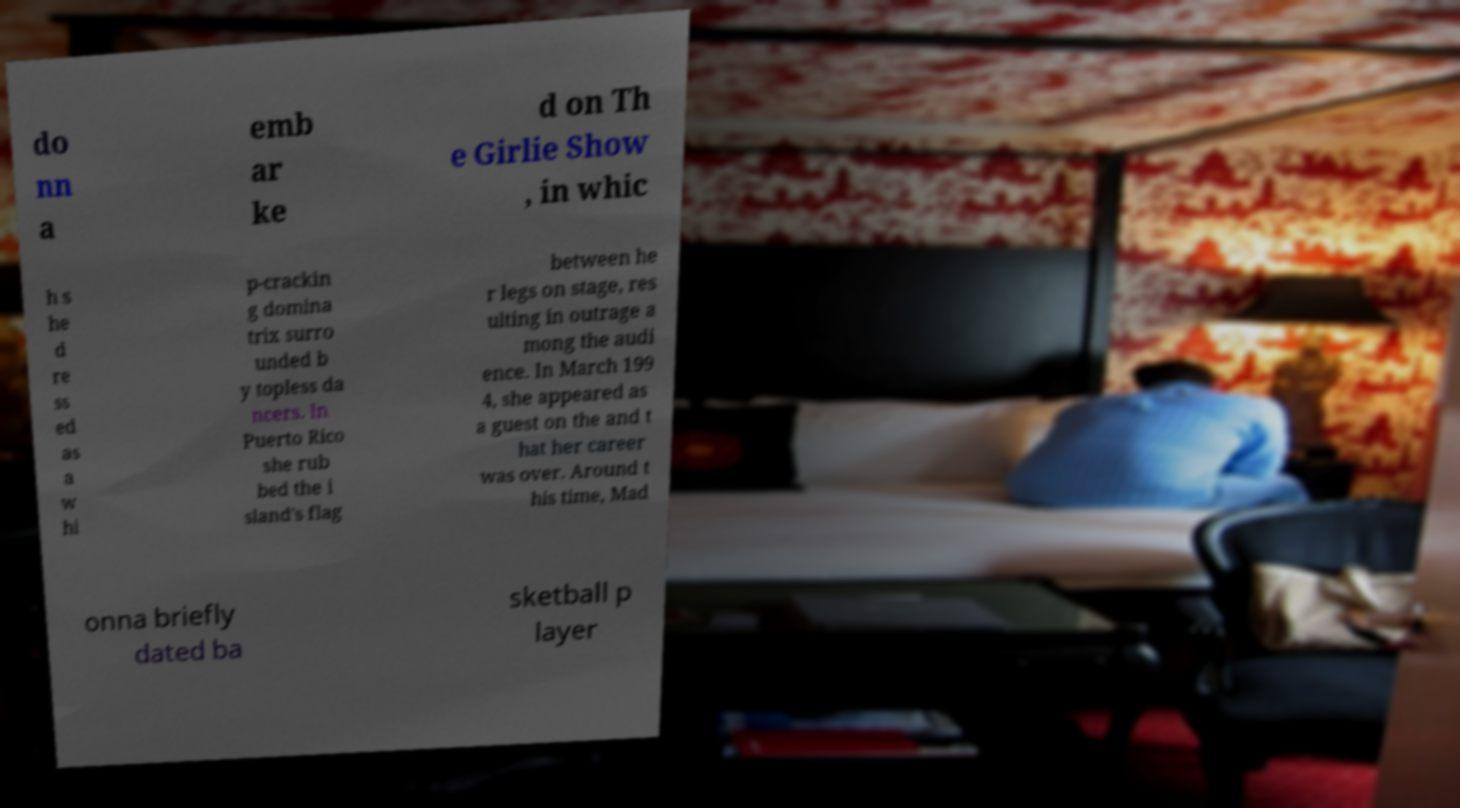Could you assist in decoding the text presented in this image and type it out clearly? do nn a emb ar ke d on Th e Girlie Show , in whic h s he d re ss ed as a w hi p-crackin g domina trix surro unded b y topless da ncers. In Puerto Rico she rub bed the i sland's flag between he r legs on stage, res ulting in outrage a mong the audi ence. In March 199 4, she appeared as a guest on the and t hat her career was over. Around t his time, Mad onna briefly dated ba sketball p layer 